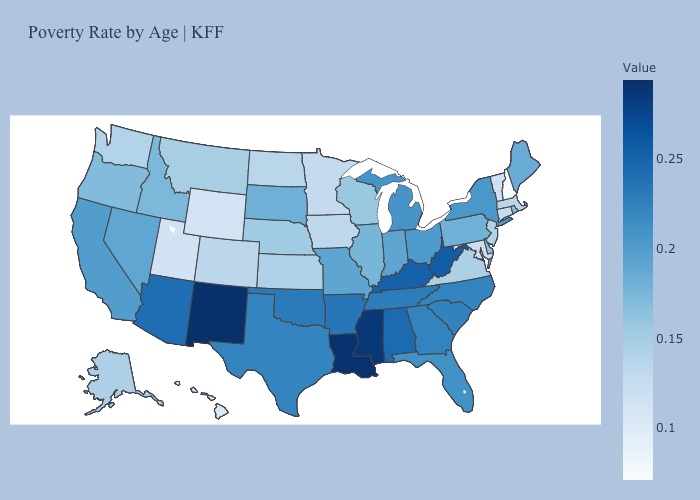Which states hav the highest value in the West?
Concise answer only. New Mexico. Among the states that border Nevada , does Utah have the lowest value?
Answer briefly. Yes. Among the states that border South Dakota , does Nebraska have the highest value?
Answer briefly. Yes. Does Minnesota have the lowest value in the MidWest?
Quick response, please. Yes. Among the states that border South Dakota , does Montana have the highest value?
Keep it brief. No. Does West Virginia have a higher value than Mississippi?
Short answer required. No. Is the legend a continuous bar?
Quick response, please. Yes. Among the states that border California , does Arizona have the highest value?
Be succinct. Yes. Which states have the lowest value in the USA?
Concise answer only. New Hampshire. 